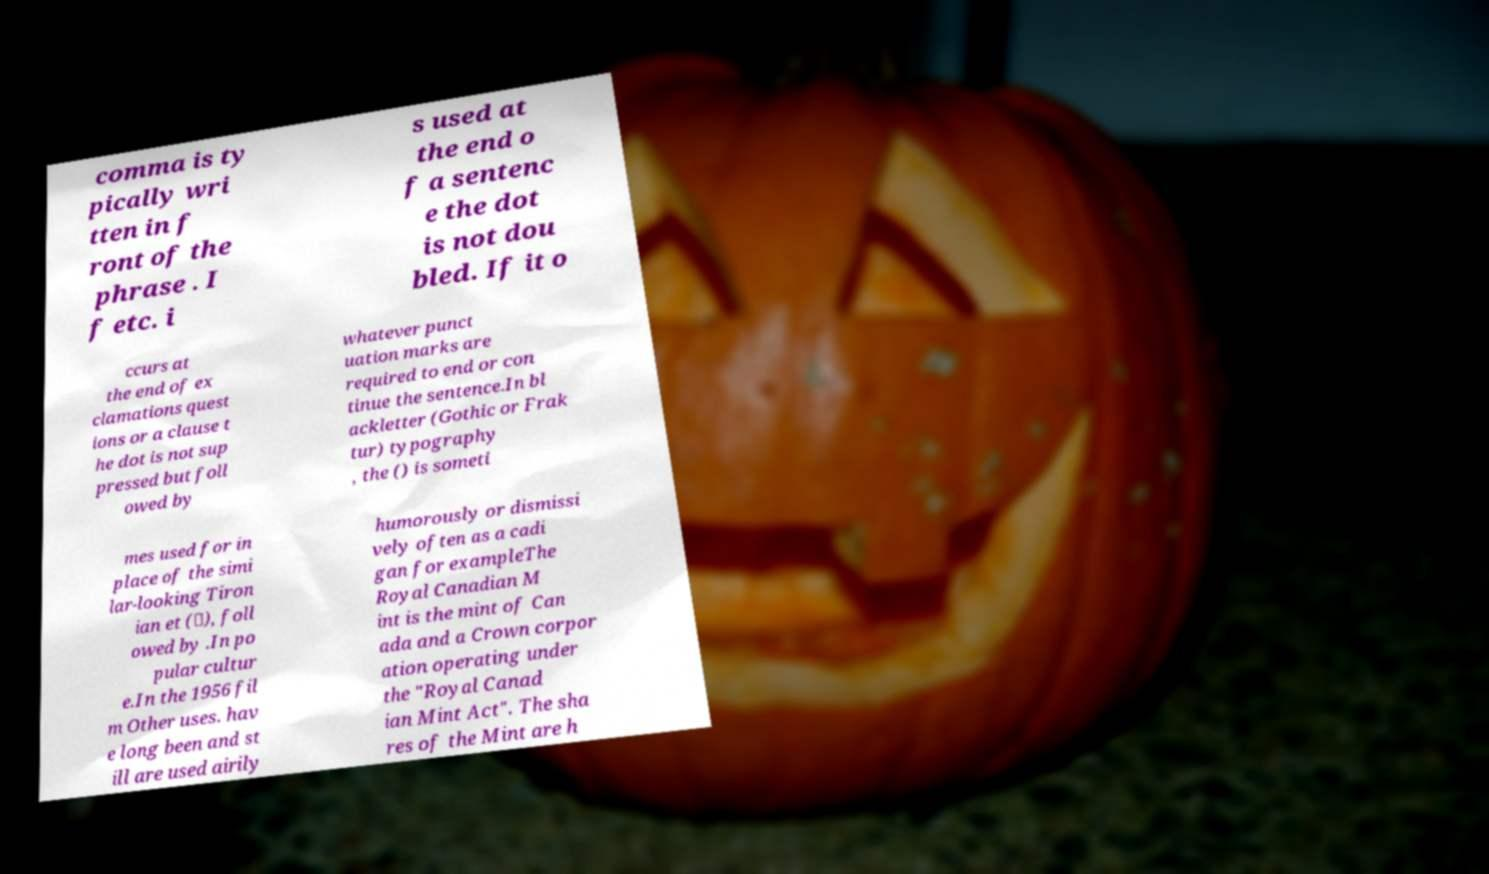What messages or text are displayed in this image? I need them in a readable, typed format. comma is ty pically wri tten in f ront of the phrase . I f etc. i s used at the end o f a sentenc e the dot is not dou bled. If it o ccurs at the end of ex clamations quest ions or a clause t he dot is not sup pressed but foll owed by whatever punct uation marks are required to end or con tinue the sentence.In bl ackletter (Gothic or Frak tur) typography , the () is someti mes used for in place of the simi lar-looking Tiron ian et (⁊), foll owed by .In po pular cultur e.In the 1956 fil m Other uses. hav e long been and st ill are used airily humorously or dismissi vely often as a cadi gan for exampleThe Royal Canadian M int is the mint of Can ada and a Crown corpor ation operating under the "Royal Canad ian Mint Act". The sha res of the Mint are h 